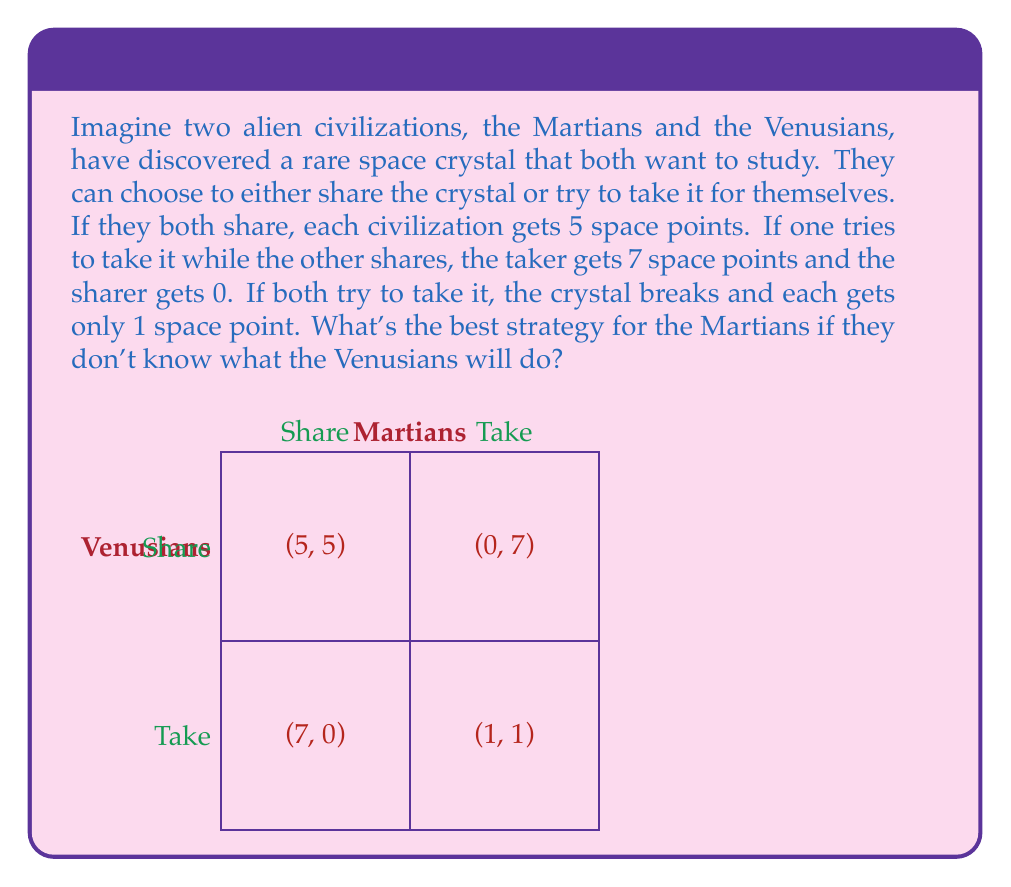Help me with this question. Let's think about this step-by-step:

1) First, we need to understand what a "dominant strategy" is. It's a strategy that's always best for a player, no matter what the other player does.

2) Let's look at the Martians' options:

   If Venusians share:
   - If Martians share, they get 5 points
   - If Martians take, they get 7 points

   If Venusians take:
   - If Martians share, they get 0 points
   - If Martians take, they get 1 point

3) We can see that no matter what the Venusians do, the Martians always get more points by choosing to take:
   - If Venusians share: 7 > 5
   - If Venusians take: 1 > 0

4) This means that "take" is the dominant strategy for the Martians.

5) However, this creates a dilemma. If both civilizations follow their dominant strategy (take), they each only get 1 point. But if they could cooperate and both share, they would each get 5 points.

6) This scenario is called a Prisoner's Dilemma. Even though cooperation would lead to a better outcome for both, the rational choice for each individual is to defect (or in this case, take).
Answer: The best strategy for the Martians is to take the crystal, as this is their dominant strategy regardless of what the Venusians choose to do. 